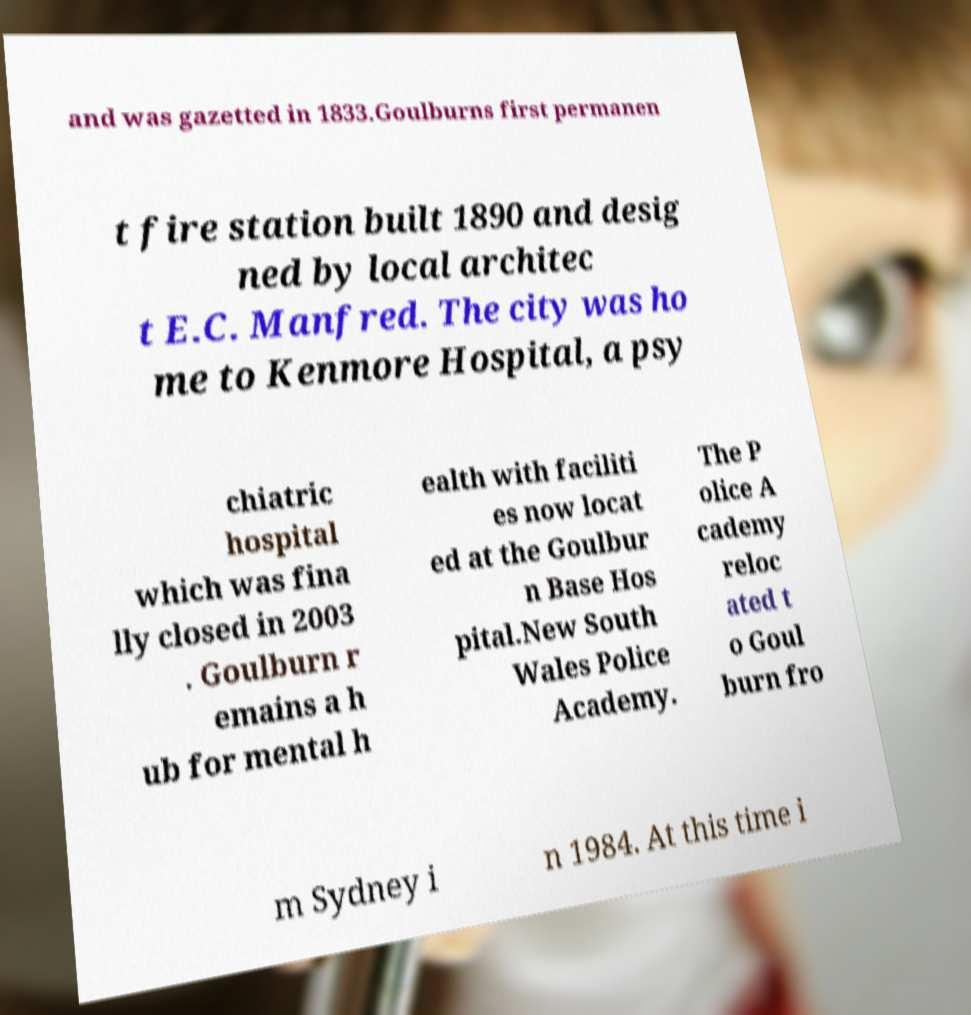I need the written content from this picture converted into text. Can you do that? and was gazetted in 1833.Goulburns first permanen t fire station built 1890 and desig ned by local architec t E.C. Manfred. The city was ho me to Kenmore Hospital, a psy chiatric hospital which was fina lly closed in 2003 . Goulburn r emains a h ub for mental h ealth with faciliti es now locat ed at the Goulbur n Base Hos pital.New South Wales Police Academy. The P olice A cademy reloc ated t o Goul burn fro m Sydney i n 1984. At this time i 